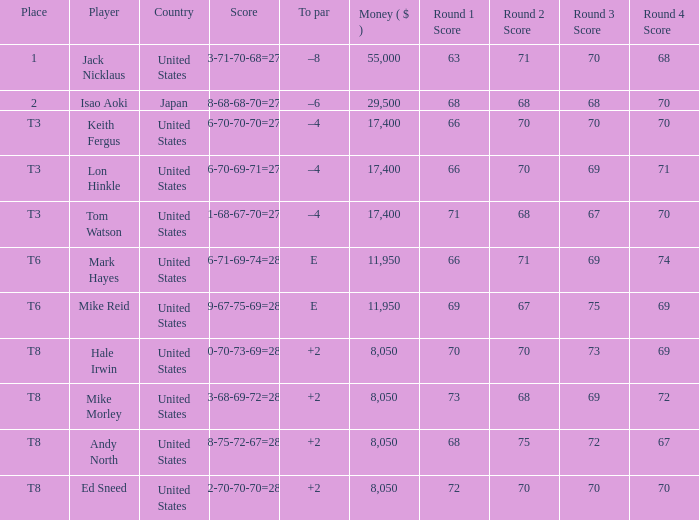What to par is located in the united states and has the player by the name of hale irwin? 2.0. 